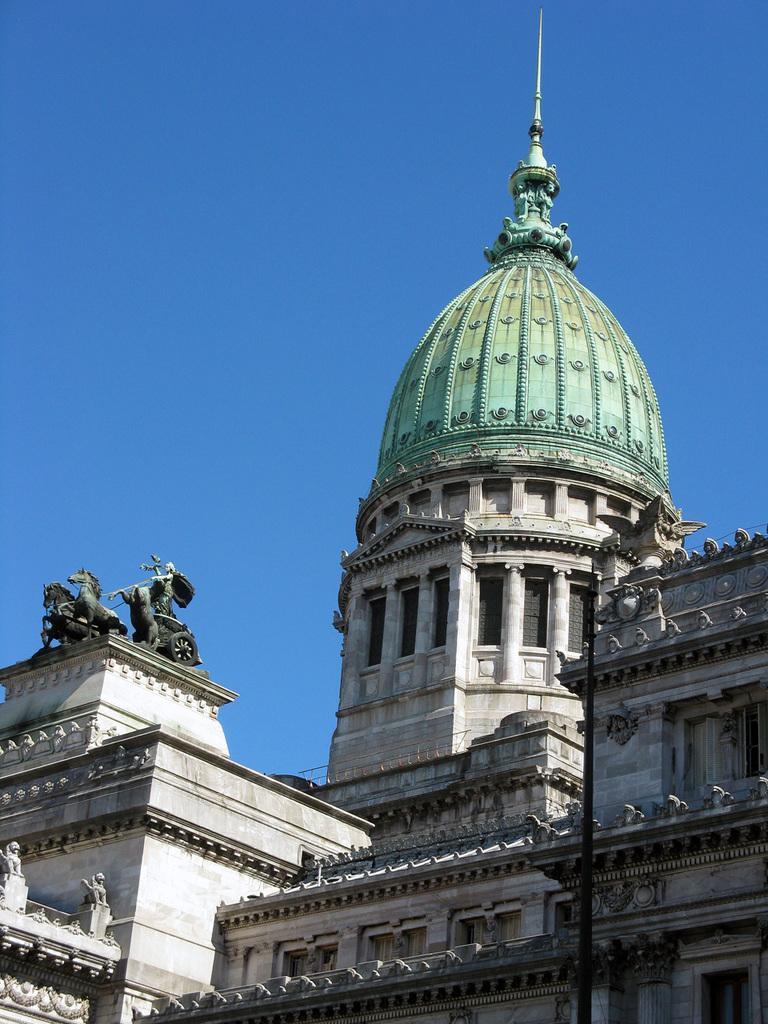In one or two sentences, can you explain what this image depicts? In the picture I can see a building which has the sculptures on it. In the background I can see the sky. 